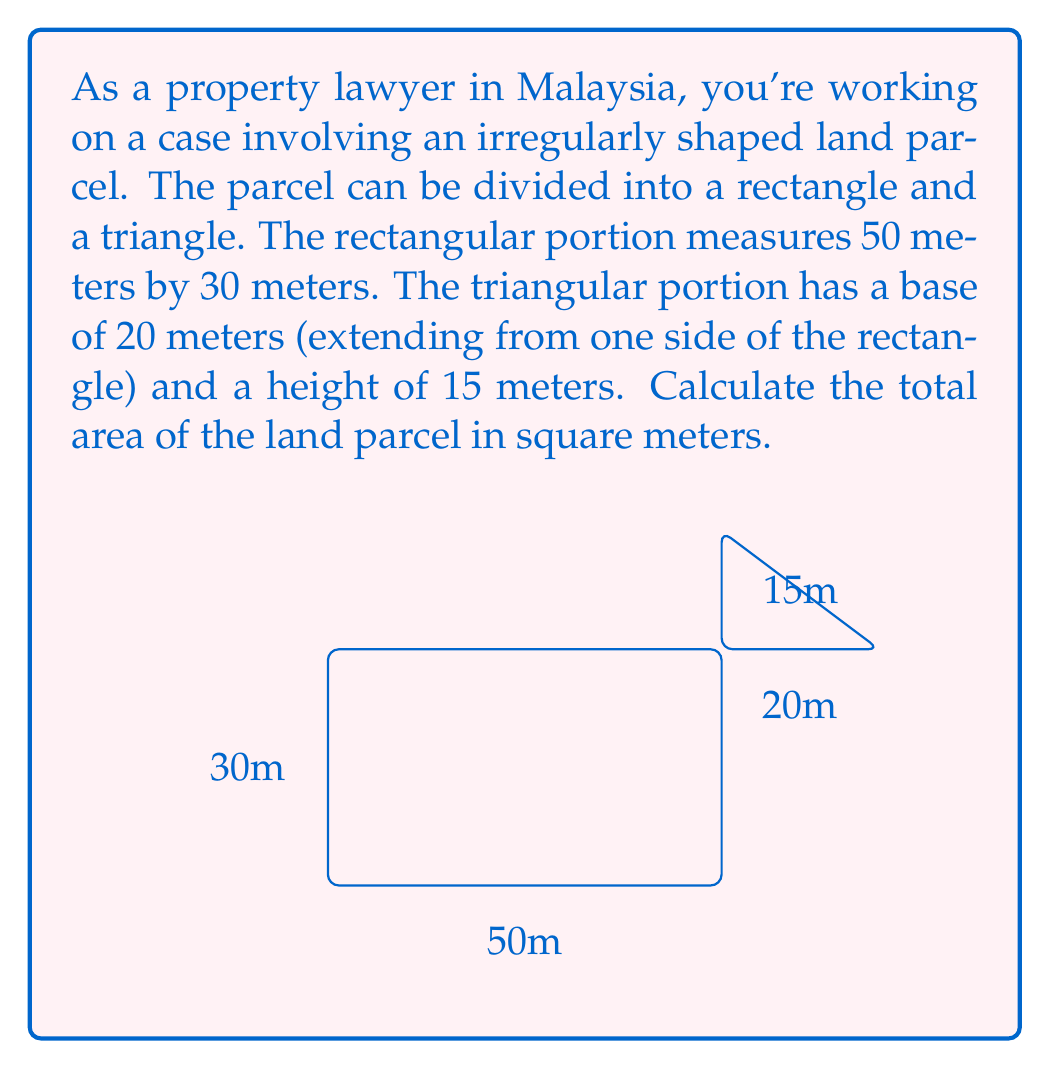Show me your answer to this math problem. To solve this problem, we need to calculate the areas of the rectangular and triangular portions separately, then add them together.

1. Area of the rectangle:
   $$ A_{rectangle} = length \times width $$
   $$ A_{rectangle} = 50 \text{ m} \times 30 \text{ m} = 1500 \text{ m}^2 $$

2. Area of the triangle:
   $$ A_{triangle} = \frac{1}{2} \times base \times height $$
   $$ A_{triangle} = \frac{1}{2} \times 20 \text{ m} \times 15 \text{ m} = 150 \text{ m}^2 $$

3. Total area of the land parcel:
   $$ A_{total} = A_{rectangle} + A_{triangle} $$
   $$ A_{total} = 1500 \text{ m}^2 + 150 \text{ m}^2 = 1650 \text{ m}^2 $$

Therefore, the total area of the irregular land parcel is 1650 square meters.
Answer: $1650 \text{ m}^2$ 